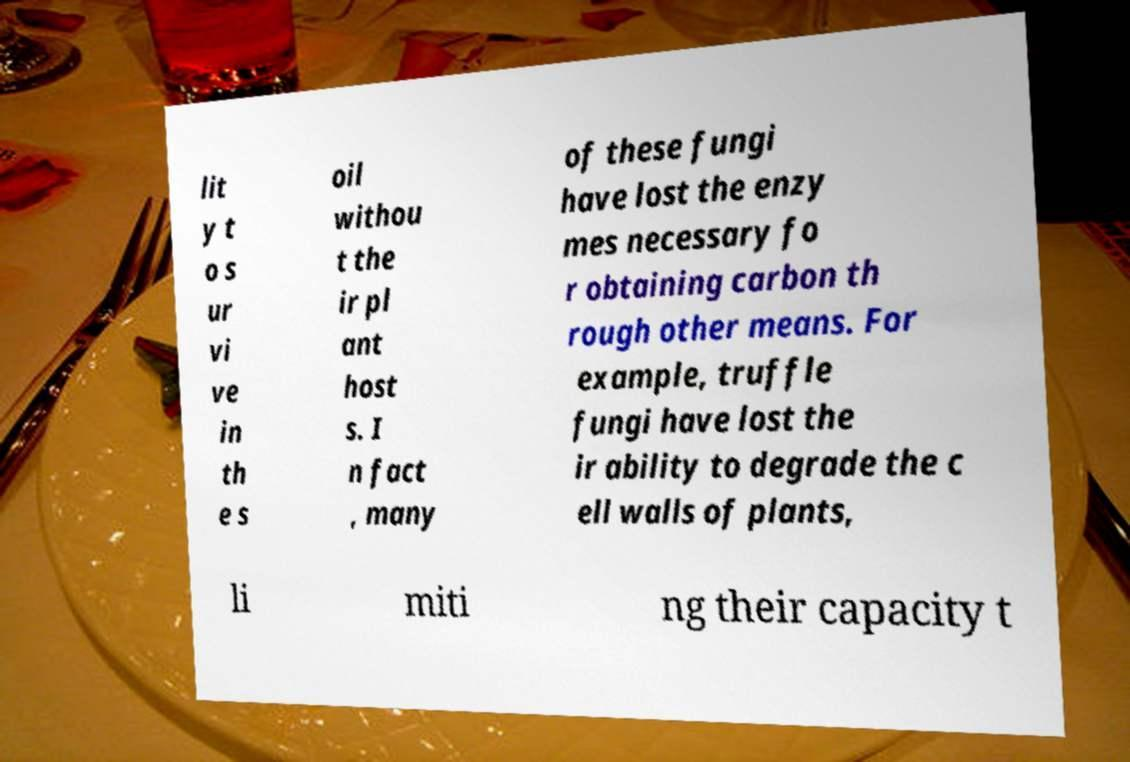Please identify and transcribe the text found in this image. lit y t o s ur vi ve in th e s oil withou t the ir pl ant host s. I n fact , many of these fungi have lost the enzy mes necessary fo r obtaining carbon th rough other means. For example, truffle fungi have lost the ir ability to degrade the c ell walls of plants, li miti ng their capacity t 